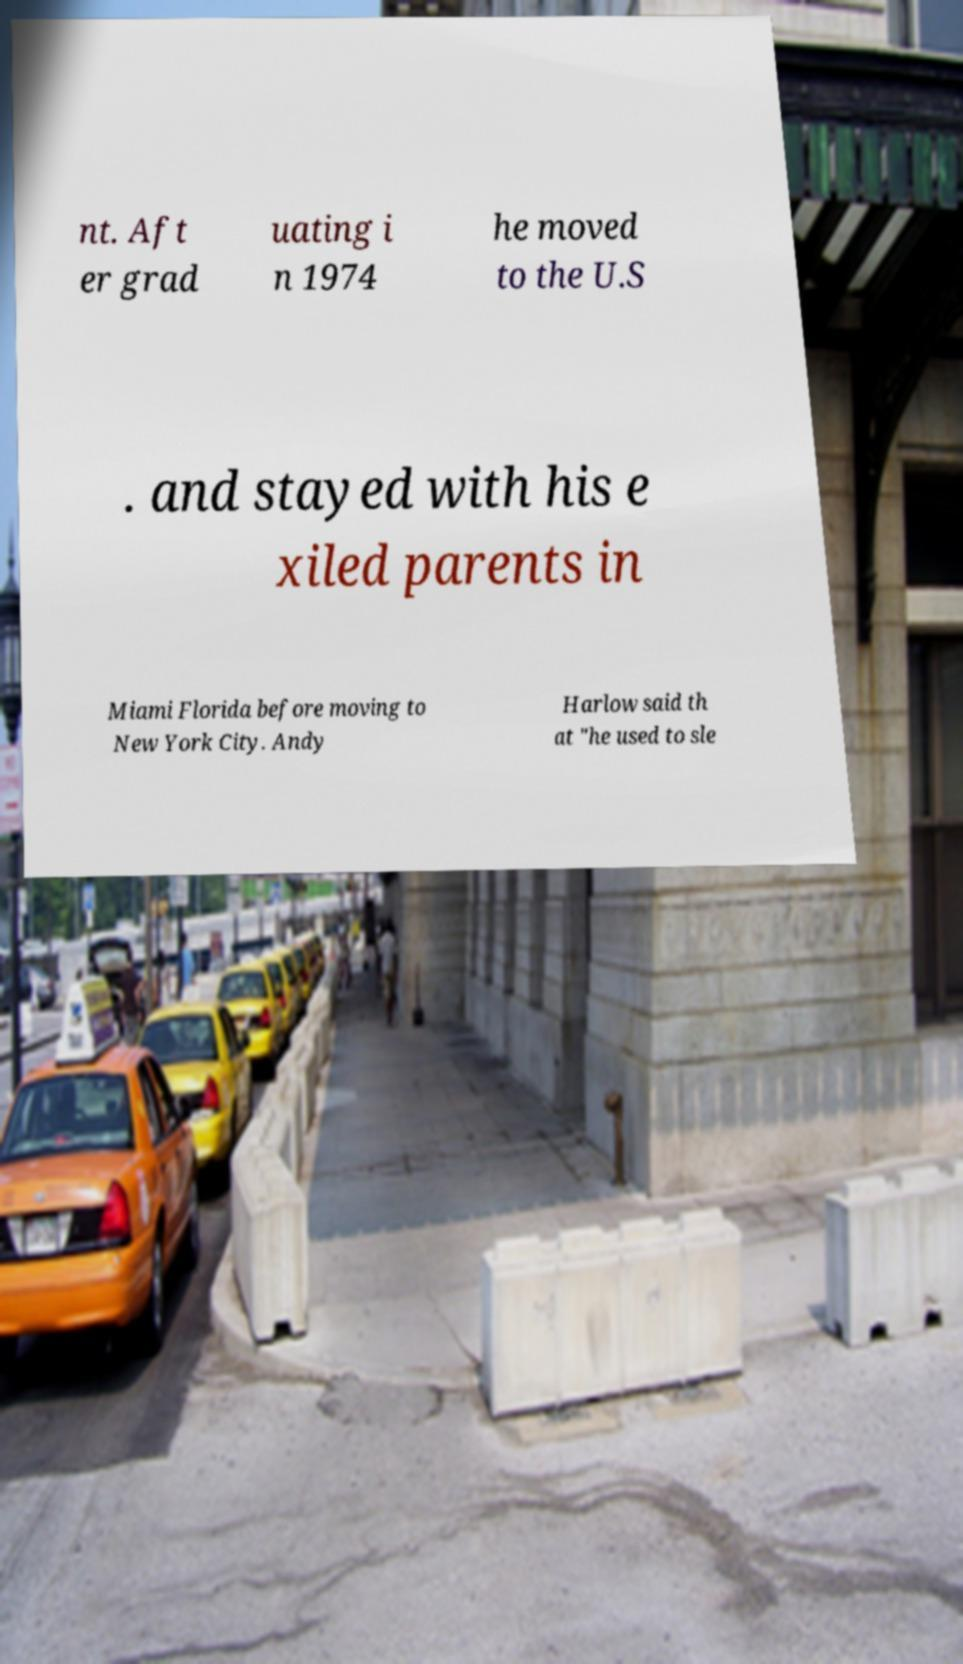What messages or text are displayed in this image? I need them in a readable, typed format. nt. Aft er grad uating i n 1974 he moved to the U.S . and stayed with his e xiled parents in Miami Florida before moving to New York City. Andy Harlow said th at "he used to sle 